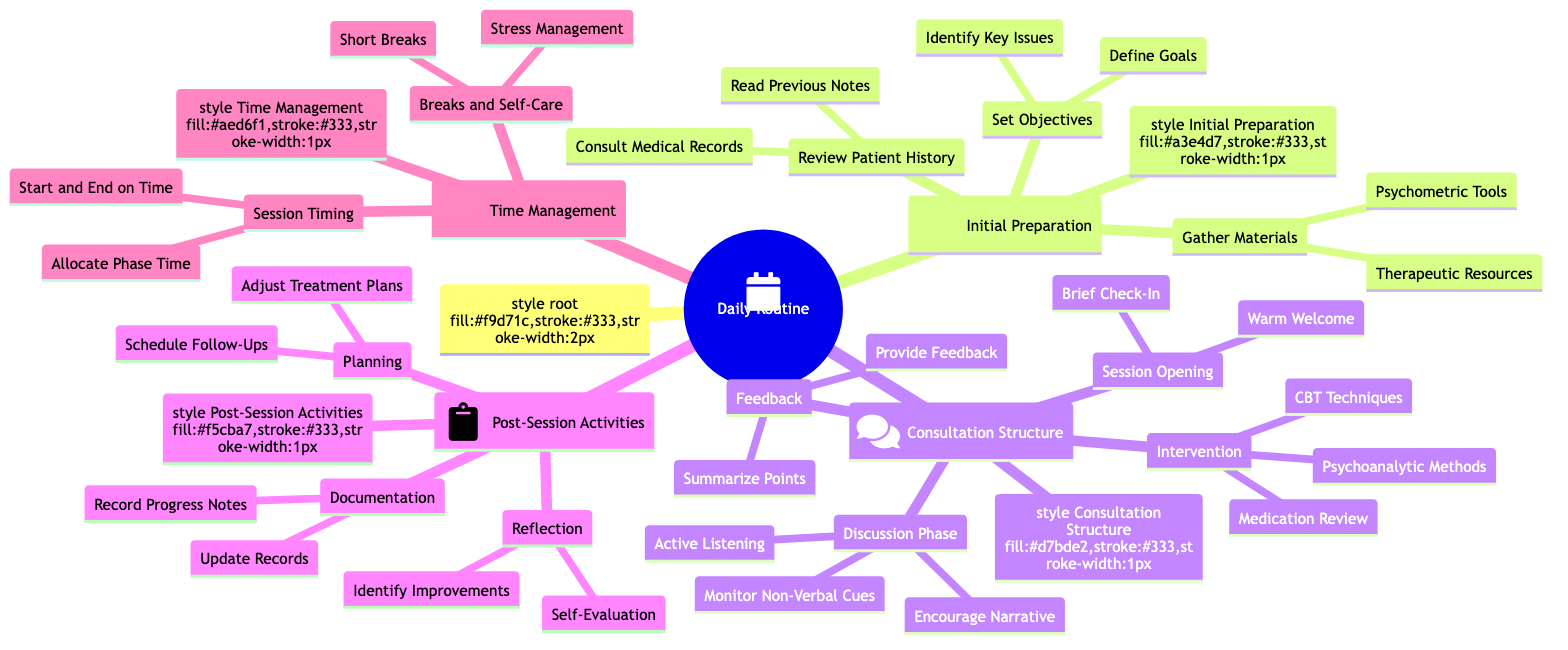What is the first main category in the diagram? The diagram starts with "Daily Routine: Structuring Patient Consultations and Therapy Sessions Effectively" as the central topic. The first main category branching from the root is "Initial Preparation."
Answer: Initial Preparation How many subcategories are under "Consultation Structure"? The "Consultation Structure" category has four subcategories listed: "Session Opening," "Discussion Phase," "Intervention and Techniques," and "Feedback and Summarization."
Answer: 4 What is one item listed under "Gather Required Materials"? "Gather Required Materials" includes two specific items: "Psychometric Tools" and "Therapeutic Resources." Any one of these items can be considered as an answer.
Answer: Psychometric Tools Which phase includes "Active Listening Techniques"? "Active Listening Techniques" is part of the "Discussion Phase" in the "Consultation Structure" category, where the focus is on engaging with the patient’s narrative effectively.
Answer: Discussion Phase In "Post-Session Activities," what follows "Documentation"? After "Documentation," the next item in the sequence is "Reflection," which focuses on the psychiatrist's self-evaluation of the session's effectiveness.
Answer: Reflection Which category addresses self-care during sessions? The "Time Management" category includes "Breaks and Self-Care," highlighting the importance of personal stress management and taking short breaks between sessions.
Answer: Time Management How many items are listed under "Session Opening"? The "Session Opening" includes two items: "Warm Welcome" and "Brief Check-In on Current State." Therefore, the total number of items is two.
Answer: 2 Identify one technique mentioned in the "Intervention and Techniques" phase. One of the techniques listed under "Intervention and Techniques" is "Cognitive Behavioral Techniques," which is a common method used in therapy to address various issues.
Answer: Cognitive Behavioral Techniques What is the final activity listed in "Post-Session Activities"? The last item under "Post-Session Activities" is "Schedule Follow-Up Sessions," indicating the planning for the next steps in the patient’s care.
Answer: Schedule Follow-Up Sessions 